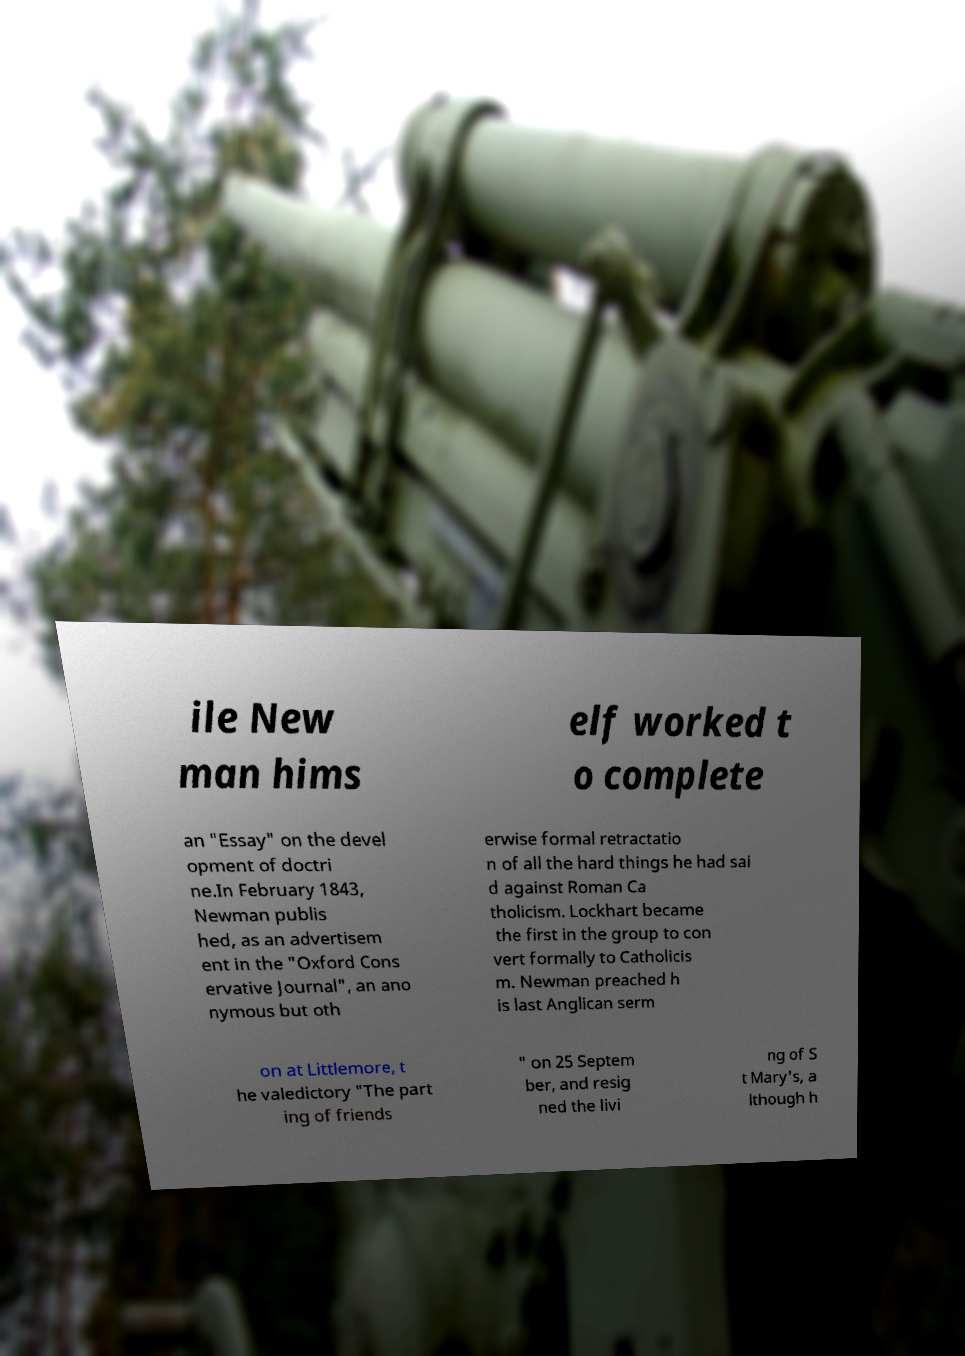I need the written content from this picture converted into text. Can you do that? ile New man hims elf worked t o complete an "Essay" on the devel opment of doctri ne.In February 1843, Newman publis hed, as an advertisem ent in the "Oxford Cons ervative Journal", an ano nymous but oth erwise formal retractatio n of all the hard things he had sai d against Roman Ca tholicism. Lockhart became the first in the group to con vert formally to Catholicis m. Newman preached h is last Anglican serm on at Littlemore, t he valedictory "The part ing of friends " on 25 Septem ber, and resig ned the livi ng of S t Mary's, a lthough h 